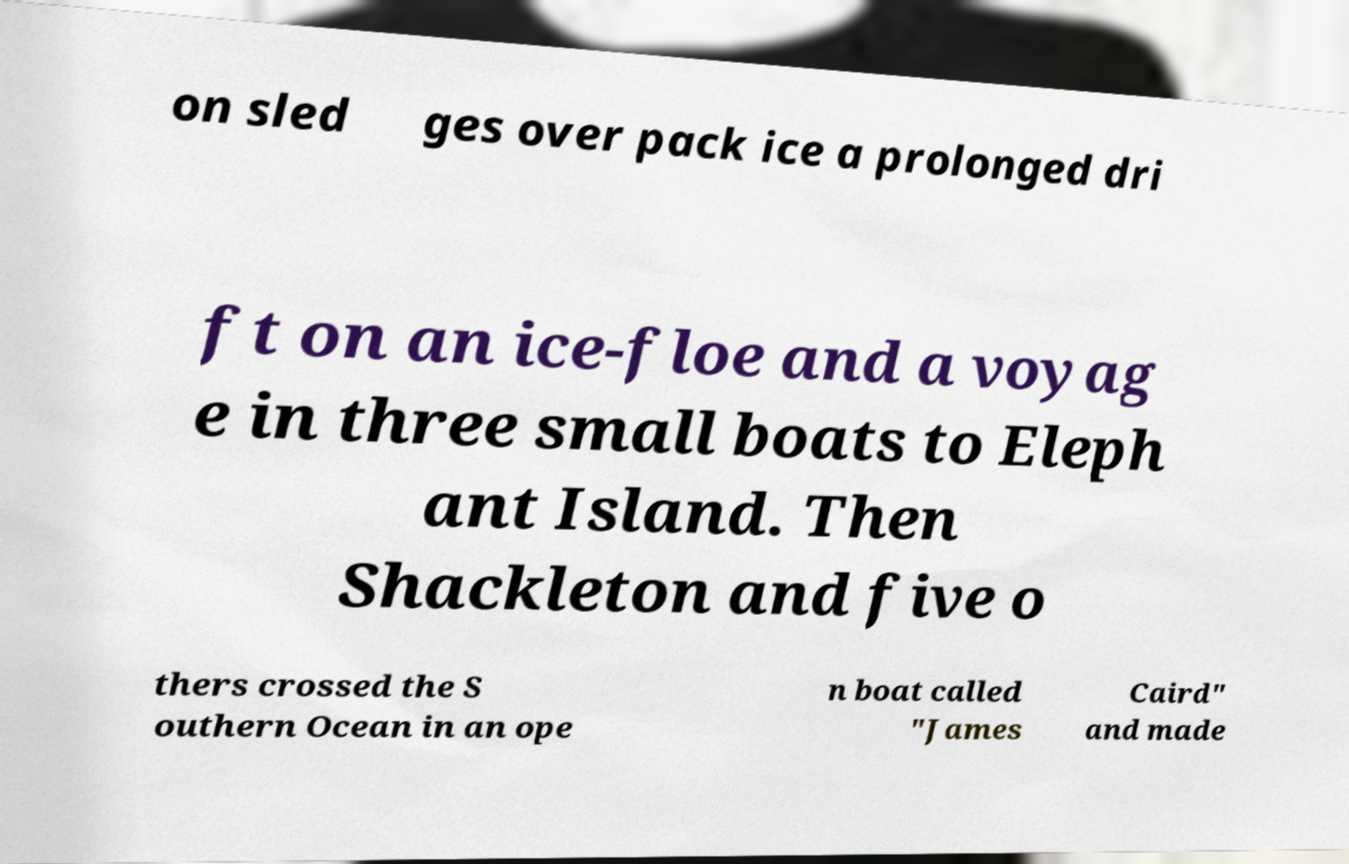What messages or text are displayed in this image? I need them in a readable, typed format. on sled ges over pack ice a prolonged dri ft on an ice-floe and a voyag e in three small boats to Eleph ant Island. Then Shackleton and five o thers crossed the S outhern Ocean in an ope n boat called "James Caird" and made 